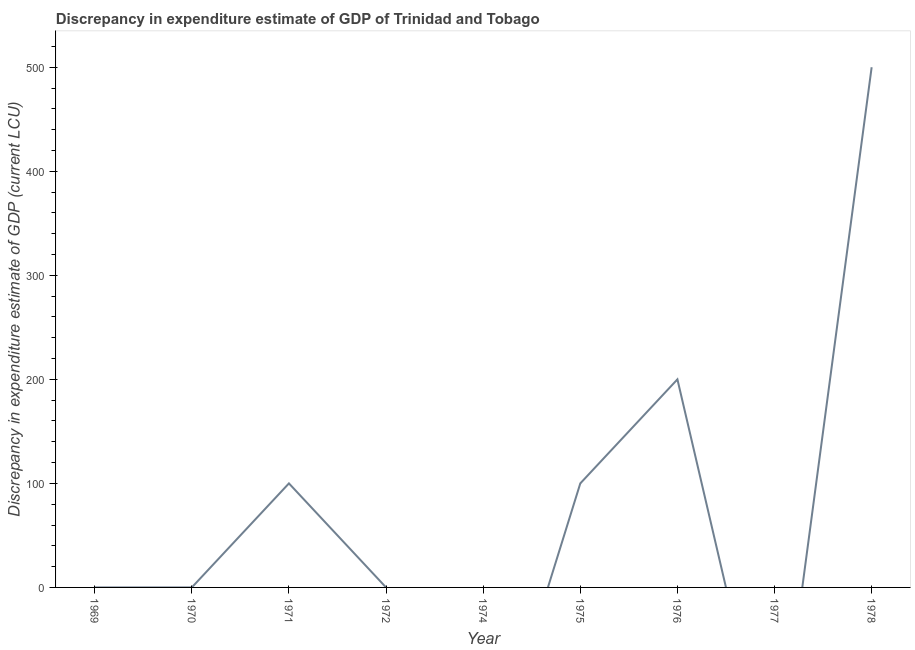What is the discrepancy in expenditure estimate of gdp in 1971?
Provide a short and direct response. 100. Across all years, what is the maximum discrepancy in expenditure estimate of gdp?
Keep it short and to the point. 500. In which year was the discrepancy in expenditure estimate of gdp maximum?
Keep it short and to the point. 1978. What is the sum of the discrepancy in expenditure estimate of gdp?
Provide a short and direct response. 900. What is the difference between the discrepancy in expenditure estimate of gdp in 1970 and 1975?
Provide a short and direct response. -100. What is the average discrepancy in expenditure estimate of gdp per year?
Give a very brief answer. 100. What is the median discrepancy in expenditure estimate of gdp?
Make the answer very short. 2e-7. In how many years, is the discrepancy in expenditure estimate of gdp greater than 460 LCU?
Ensure brevity in your answer.  1. What is the ratio of the discrepancy in expenditure estimate of gdp in 1975 to that in 1978?
Ensure brevity in your answer.  0.2. Is the difference between the discrepancy in expenditure estimate of gdp in 1970 and 1975 greater than the difference between any two years?
Provide a succinct answer. No. What is the difference between the highest and the second highest discrepancy in expenditure estimate of gdp?
Your response must be concise. 300. Is the sum of the discrepancy in expenditure estimate of gdp in 1970 and 1978 greater than the maximum discrepancy in expenditure estimate of gdp across all years?
Your response must be concise. Yes. What is the difference between the highest and the lowest discrepancy in expenditure estimate of gdp?
Your answer should be compact. 500. Does the discrepancy in expenditure estimate of gdp monotonically increase over the years?
Offer a very short reply. No. How many lines are there?
Keep it short and to the point. 1. What is the difference between two consecutive major ticks on the Y-axis?
Provide a succinct answer. 100. Are the values on the major ticks of Y-axis written in scientific E-notation?
Offer a very short reply. No. What is the title of the graph?
Offer a terse response. Discrepancy in expenditure estimate of GDP of Trinidad and Tobago. What is the label or title of the Y-axis?
Provide a short and direct response. Discrepancy in expenditure estimate of GDP (current LCU). What is the Discrepancy in expenditure estimate of GDP (current LCU) in 1969?
Ensure brevity in your answer.  2e-7. What is the Discrepancy in expenditure estimate of GDP (current LCU) in 1970?
Make the answer very short. 1.2e-7. What is the Discrepancy in expenditure estimate of GDP (current LCU) of 1971?
Give a very brief answer. 100. What is the Discrepancy in expenditure estimate of GDP (current LCU) of 1974?
Your response must be concise. 0. What is the Discrepancy in expenditure estimate of GDP (current LCU) of 1975?
Your response must be concise. 100. What is the Discrepancy in expenditure estimate of GDP (current LCU) of 1976?
Provide a succinct answer. 200. What is the Discrepancy in expenditure estimate of GDP (current LCU) in 1978?
Your response must be concise. 500. What is the difference between the Discrepancy in expenditure estimate of GDP (current LCU) in 1969 and 1970?
Offer a very short reply. 0. What is the difference between the Discrepancy in expenditure estimate of GDP (current LCU) in 1969 and 1971?
Offer a terse response. -100. What is the difference between the Discrepancy in expenditure estimate of GDP (current LCU) in 1969 and 1975?
Provide a short and direct response. -100. What is the difference between the Discrepancy in expenditure estimate of GDP (current LCU) in 1969 and 1976?
Give a very brief answer. -200. What is the difference between the Discrepancy in expenditure estimate of GDP (current LCU) in 1969 and 1978?
Your answer should be compact. -500. What is the difference between the Discrepancy in expenditure estimate of GDP (current LCU) in 1970 and 1971?
Your answer should be compact. -100. What is the difference between the Discrepancy in expenditure estimate of GDP (current LCU) in 1970 and 1975?
Your answer should be very brief. -100. What is the difference between the Discrepancy in expenditure estimate of GDP (current LCU) in 1970 and 1976?
Offer a terse response. -200. What is the difference between the Discrepancy in expenditure estimate of GDP (current LCU) in 1970 and 1978?
Ensure brevity in your answer.  -500. What is the difference between the Discrepancy in expenditure estimate of GDP (current LCU) in 1971 and 1976?
Your answer should be very brief. -100. What is the difference between the Discrepancy in expenditure estimate of GDP (current LCU) in 1971 and 1978?
Your response must be concise. -400. What is the difference between the Discrepancy in expenditure estimate of GDP (current LCU) in 1975 and 1976?
Your answer should be very brief. -100. What is the difference between the Discrepancy in expenditure estimate of GDP (current LCU) in 1975 and 1978?
Keep it short and to the point. -400. What is the difference between the Discrepancy in expenditure estimate of GDP (current LCU) in 1976 and 1978?
Keep it short and to the point. -300. What is the ratio of the Discrepancy in expenditure estimate of GDP (current LCU) in 1969 to that in 1970?
Offer a terse response. 1.67. What is the ratio of the Discrepancy in expenditure estimate of GDP (current LCU) in 1969 to that in 1975?
Give a very brief answer. 0. What is the ratio of the Discrepancy in expenditure estimate of GDP (current LCU) in 1970 to that in 1975?
Offer a very short reply. 0. What is the ratio of the Discrepancy in expenditure estimate of GDP (current LCU) in 1970 to that in 1976?
Your answer should be compact. 0. What is the ratio of the Discrepancy in expenditure estimate of GDP (current LCU) in 1970 to that in 1978?
Your answer should be very brief. 0. What is the ratio of the Discrepancy in expenditure estimate of GDP (current LCU) in 1971 to that in 1975?
Offer a terse response. 1. What is the ratio of the Discrepancy in expenditure estimate of GDP (current LCU) in 1971 to that in 1978?
Offer a very short reply. 0.2. What is the ratio of the Discrepancy in expenditure estimate of GDP (current LCU) in 1975 to that in 1976?
Your response must be concise. 0.5. What is the ratio of the Discrepancy in expenditure estimate of GDP (current LCU) in 1975 to that in 1978?
Make the answer very short. 0.2. What is the ratio of the Discrepancy in expenditure estimate of GDP (current LCU) in 1976 to that in 1978?
Provide a short and direct response. 0.4. 